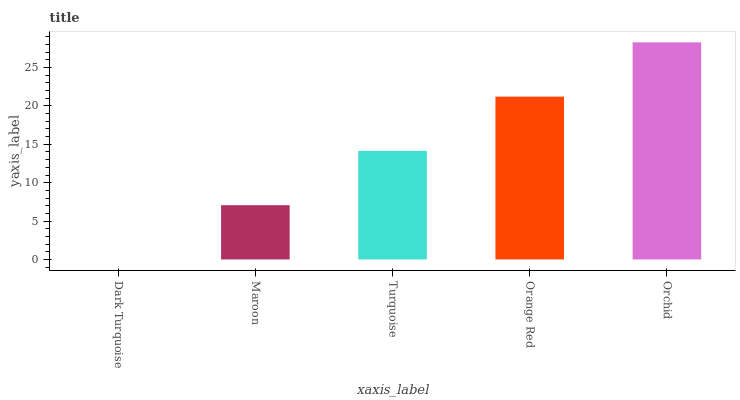Is Dark Turquoise the minimum?
Answer yes or no. Yes. Is Orchid the maximum?
Answer yes or no. Yes. Is Maroon the minimum?
Answer yes or no. No. Is Maroon the maximum?
Answer yes or no. No. Is Maroon greater than Dark Turquoise?
Answer yes or no. Yes. Is Dark Turquoise less than Maroon?
Answer yes or no. Yes. Is Dark Turquoise greater than Maroon?
Answer yes or no. No. Is Maroon less than Dark Turquoise?
Answer yes or no. No. Is Turquoise the high median?
Answer yes or no. Yes. Is Turquoise the low median?
Answer yes or no. Yes. Is Maroon the high median?
Answer yes or no. No. Is Orchid the low median?
Answer yes or no. No. 